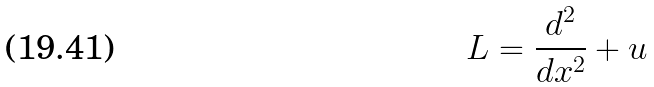<formula> <loc_0><loc_0><loc_500><loc_500>L = \frac { d ^ { 2 } } { d x ^ { 2 } } + u</formula> 